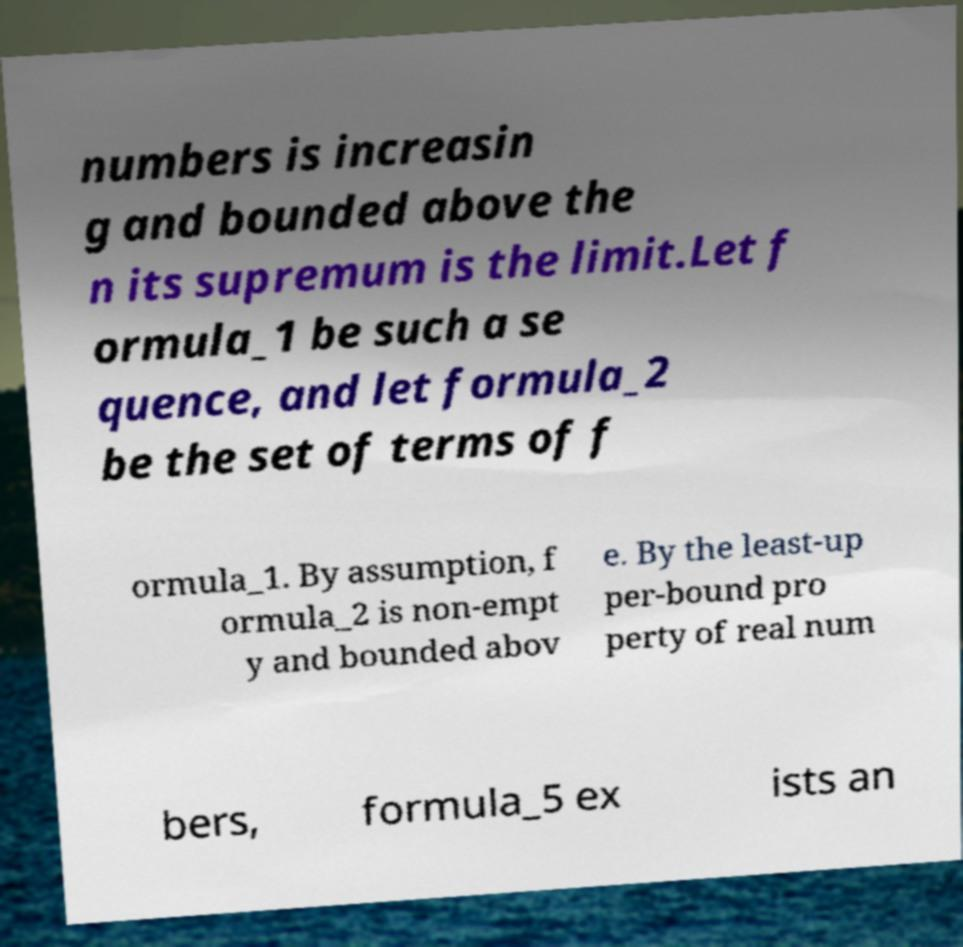I need the written content from this picture converted into text. Can you do that? numbers is increasin g and bounded above the n its supremum is the limit.Let f ormula_1 be such a se quence, and let formula_2 be the set of terms of f ormula_1. By assumption, f ormula_2 is non-empt y and bounded abov e. By the least-up per-bound pro perty of real num bers, formula_5 ex ists an 